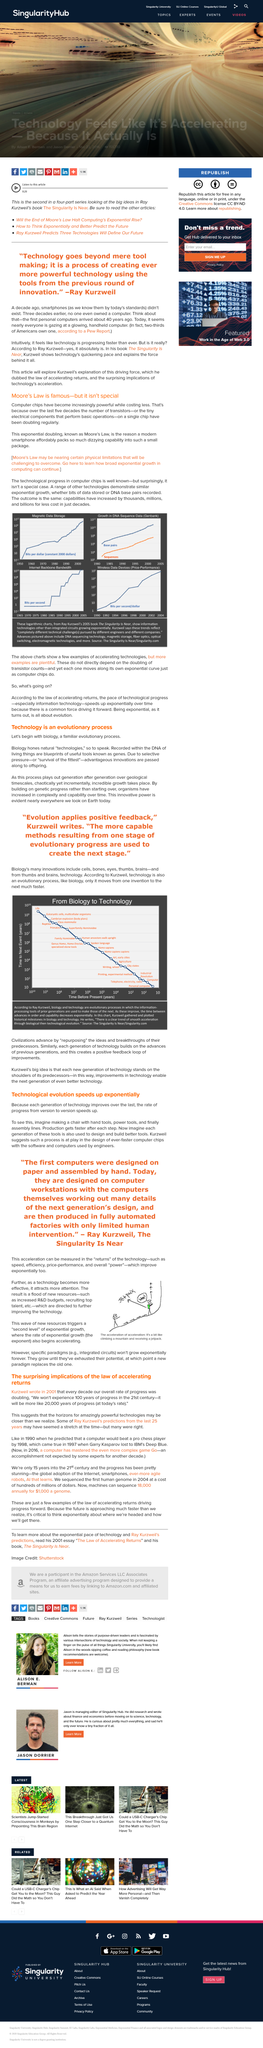Identify some key points in this picture. The acceleration of technology can be measured in its returns, such as its speed, efficiency, price-performance, and overall power, providing a comprehensive understanding of its development and impact. Transistors are small electrical components that are capable of performing basic operations, such as amplification and switching, through the control of the flow of electrical current. Ray Kurzweil argues that biology and technology are evolutionary processes. There is a clear trend of acceleration in the evolution of biological and technological systems. The increased focus on this technology has led to a surge in resources, such as increased R&D budgets and the recruitment of highly skilled personnel. 